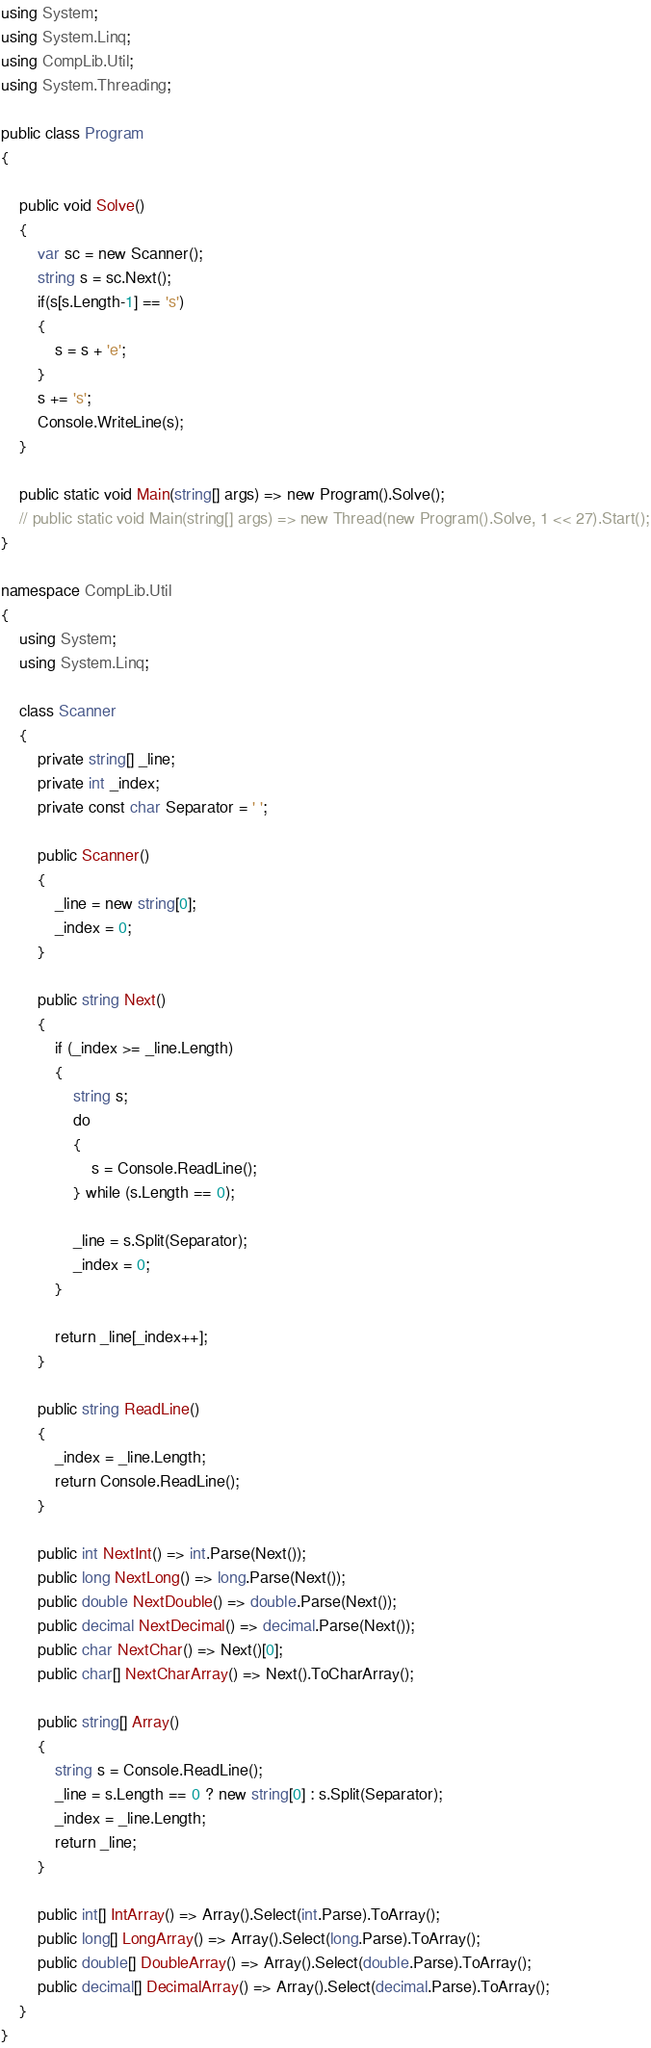Convert code to text. <code><loc_0><loc_0><loc_500><loc_500><_C#_>using System;
using System.Linq;
using CompLib.Util;
using System.Threading;

public class Program
{

    public void Solve()
    {
        var sc = new Scanner();
        string s = sc.Next();
        if(s[s.Length-1] == 's')
        {
            s = s + 'e';
        }
        s += 's';
        Console.WriteLine(s);
    }

    public static void Main(string[] args) => new Program().Solve();
    // public static void Main(string[] args) => new Thread(new Program().Solve, 1 << 27).Start();
}

namespace CompLib.Util
{
    using System;
    using System.Linq;

    class Scanner
    {
        private string[] _line;
        private int _index;
        private const char Separator = ' ';

        public Scanner()
        {
            _line = new string[0];
            _index = 0;
        }

        public string Next()
        {
            if (_index >= _line.Length)
            {
                string s;
                do
                {
                    s = Console.ReadLine();
                } while (s.Length == 0);

                _line = s.Split(Separator);
                _index = 0;
            }

            return _line[_index++];
        }

        public string ReadLine()
        {
            _index = _line.Length;
            return Console.ReadLine();
        }

        public int NextInt() => int.Parse(Next());
        public long NextLong() => long.Parse(Next());
        public double NextDouble() => double.Parse(Next());
        public decimal NextDecimal() => decimal.Parse(Next());
        public char NextChar() => Next()[0];
        public char[] NextCharArray() => Next().ToCharArray();

        public string[] Array()
        {
            string s = Console.ReadLine();
            _line = s.Length == 0 ? new string[0] : s.Split(Separator);
            _index = _line.Length;
            return _line;
        }

        public int[] IntArray() => Array().Select(int.Parse).ToArray();
        public long[] LongArray() => Array().Select(long.Parse).ToArray();
        public double[] DoubleArray() => Array().Select(double.Parse).ToArray();
        public decimal[] DecimalArray() => Array().Select(decimal.Parse).ToArray();
    }
}
</code> 